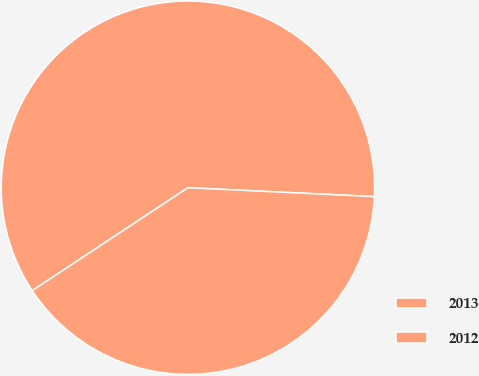Convert chart to OTSL. <chart><loc_0><loc_0><loc_500><loc_500><pie_chart><fcel>2013<fcel>2012<nl><fcel>60.06%<fcel>39.94%<nl></chart> 